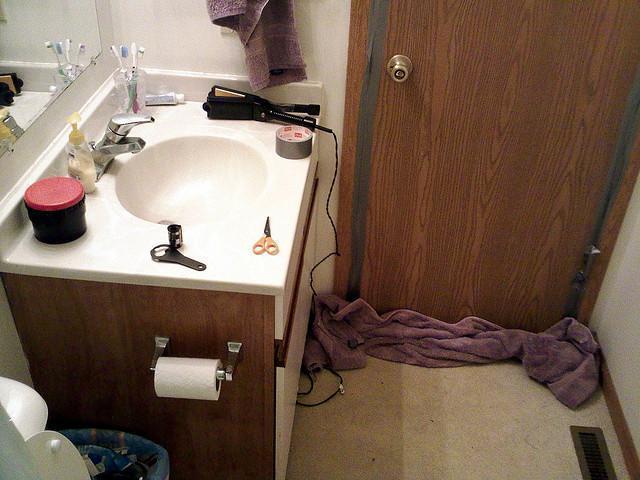How many people are to the left of the man in the air?
Give a very brief answer. 0. 